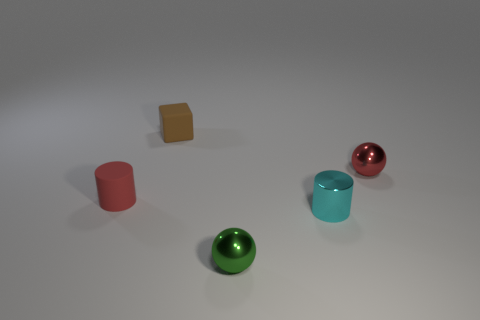Add 2 tiny rubber things. How many objects exist? 7 Subtract all cubes. How many objects are left? 4 Subtract all brown spheres. How many cyan cylinders are left? 1 Subtract 1 red cylinders. How many objects are left? 4 Subtract 1 cubes. How many cubes are left? 0 Subtract all red cylinders. Subtract all red blocks. How many cylinders are left? 1 Subtract all small red things. Subtract all tiny red things. How many objects are left? 1 Add 5 small cubes. How many small cubes are left? 6 Add 4 purple rubber blocks. How many purple rubber blocks exist? 4 